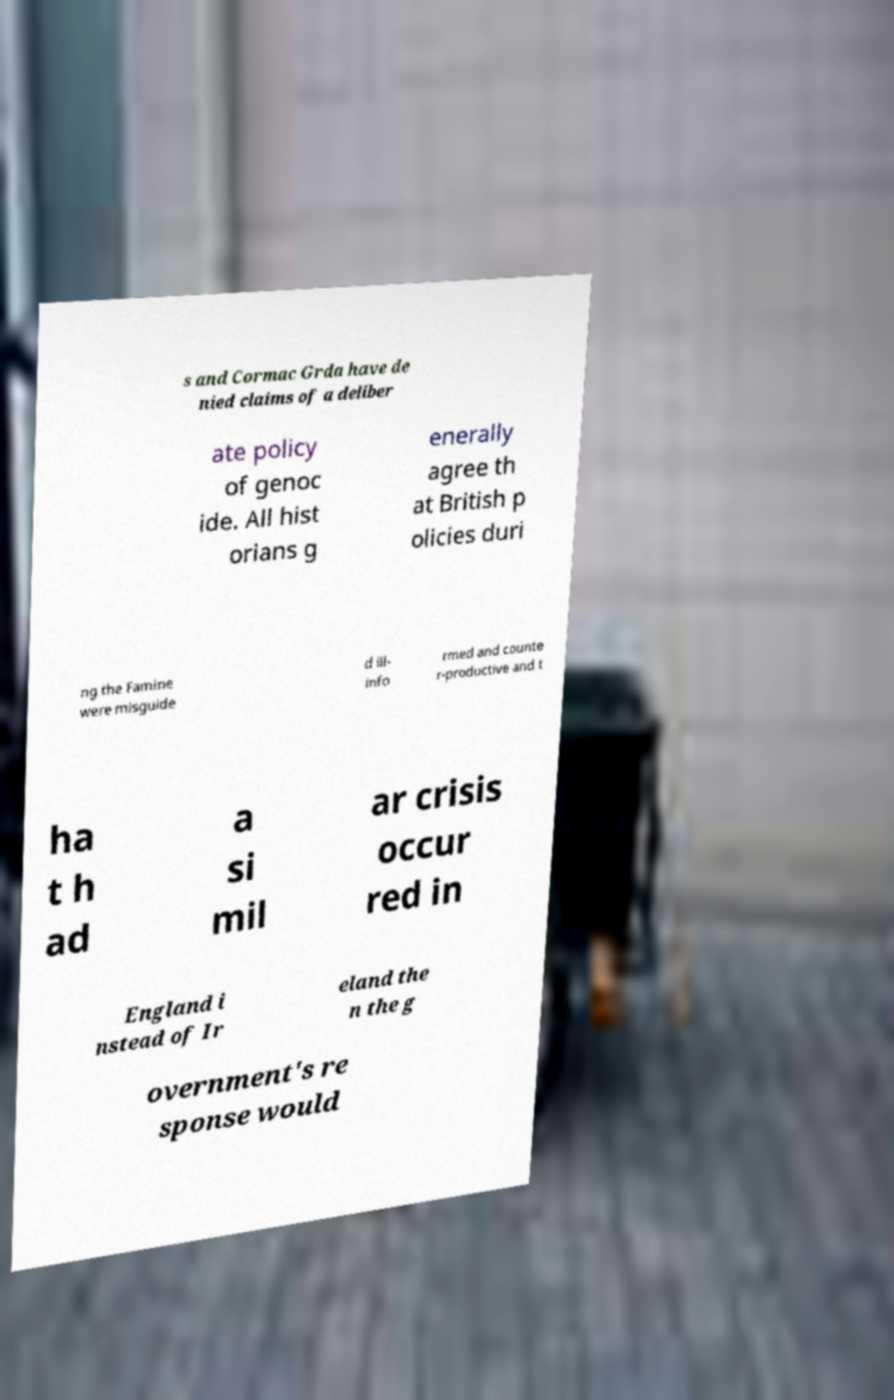Could you assist in decoding the text presented in this image and type it out clearly? s and Cormac Grda have de nied claims of a deliber ate policy of genoc ide. All hist orians g enerally agree th at British p olicies duri ng the Famine were misguide d ill- info rmed and counte r-productive and t ha t h ad a si mil ar crisis occur red in England i nstead of Ir eland the n the g overnment's re sponse would 